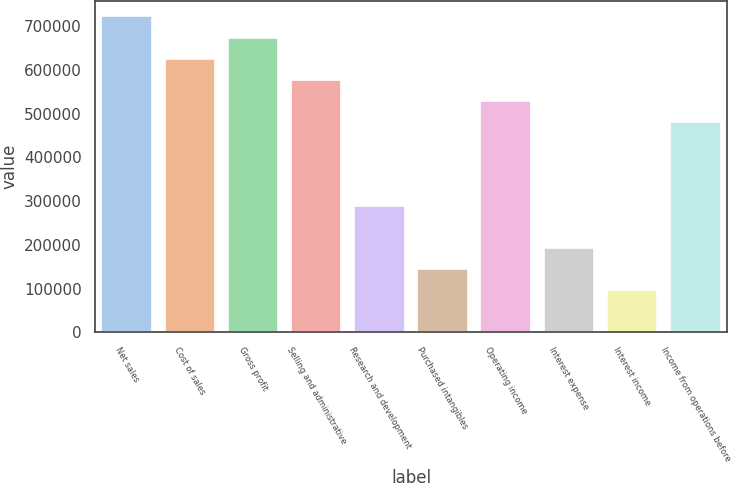<chart> <loc_0><loc_0><loc_500><loc_500><bar_chart><fcel>Net sales<fcel>Cost of sales<fcel>Gross profit<fcel>Selling and administrative<fcel>Research and development<fcel>Purchased intangibles<fcel>Operating income<fcel>Interest expense<fcel>Interest income<fcel>Income from operations before<nl><fcel>722701<fcel>626341<fcel>674521<fcel>578161<fcel>289081<fcel>144541<fcel>529981<fcel>192721<fcel>96361.1<fcel>481801<nl></chart> 